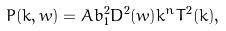Convert formula to latex. <formula><loc_0><loc_0><loc_500><loc_500>P ( k , w ) = A b _ { 1 } ^ { 2 } D ^ { 2 } ( w ) k ^ { n } T ^ { 2 } ( k ) ,</formula> 